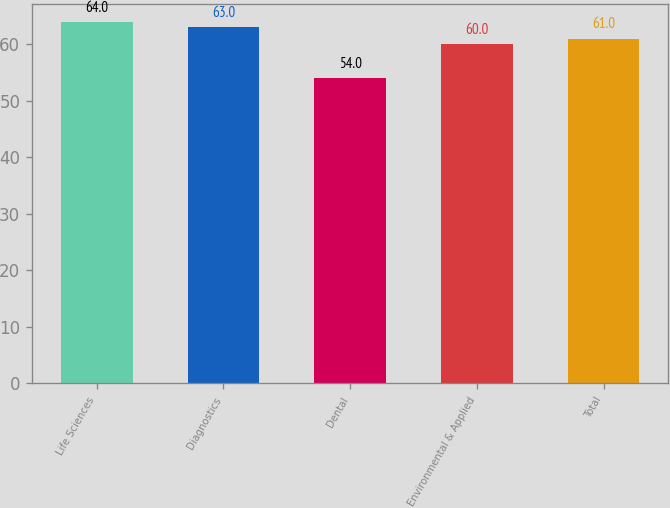Convert chart to OTSL. <chart><loc_0><loc_0><loc_500><loc_500><bar_chart><fcel>Life Sciences<fcel>Diagnostics<fcel>Dental<fcel>Environmental & Applied<fcel>Total<nl><fcel>64<fcel>63<fcel>54<fcel>60<fcel>61<nl></chart> 